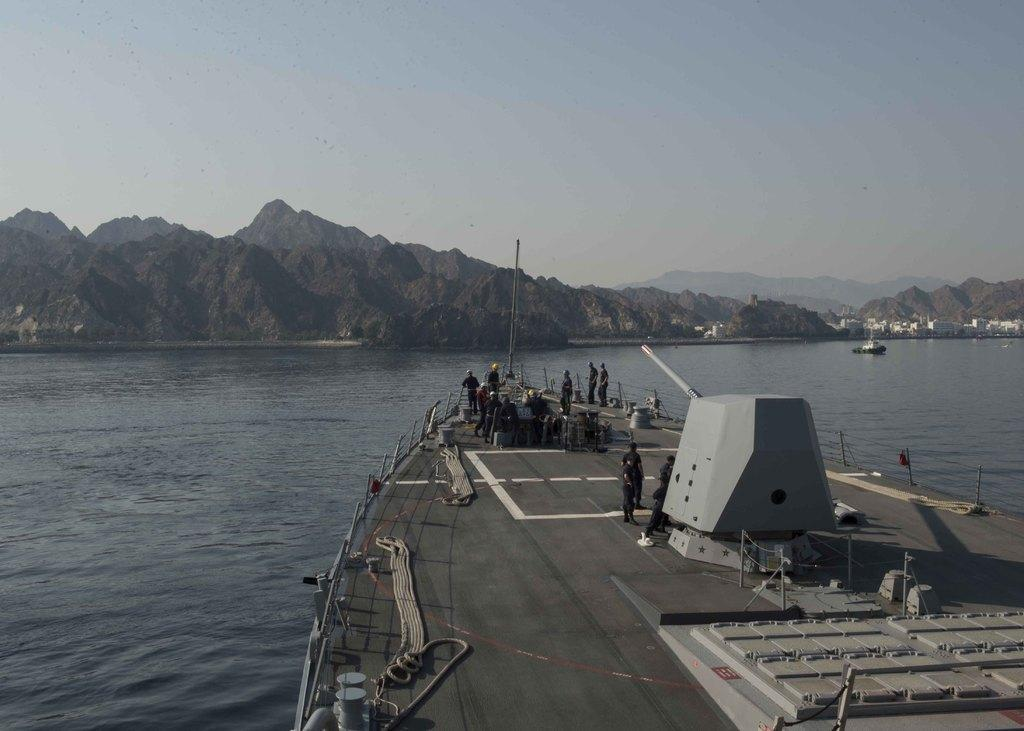What is the main subject of the image? The main subject of the image is a ship. Where is the ship located? The ship is on a river. Are there any people on the ship? Yes, there are people on the ship. What can be seen on the ship? There are ropes and metal structures on the ship. What is visible in the background of the image? In the background of the image, there are hills, buildings, and the sky. Can you see any fairies flying around the ship in the image? No, there are no fairies visible in the image. What type of steel is used to construct the metal structures on the ship? The image does not provide information about the type of steel used for the metal structures on the ship. 